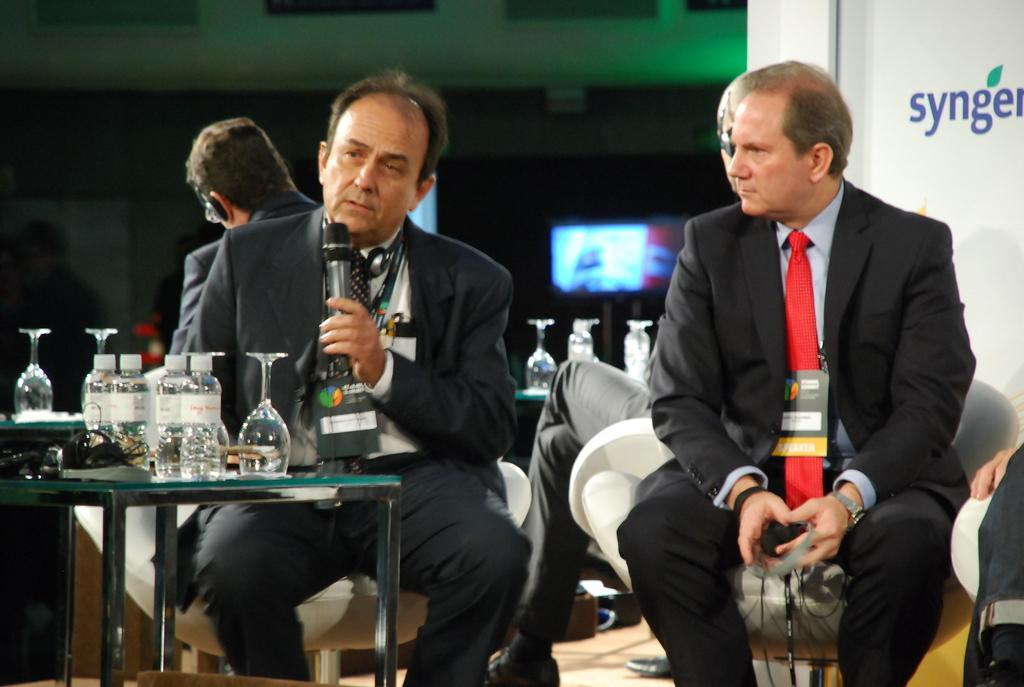Describe this image in one or two sentences. The person in the left is sitting and speaking in front of a mic and there is another person sitting beside him and there is a table in front of them which has water bottles and glasses on it and there are two other people sitting behind them. 